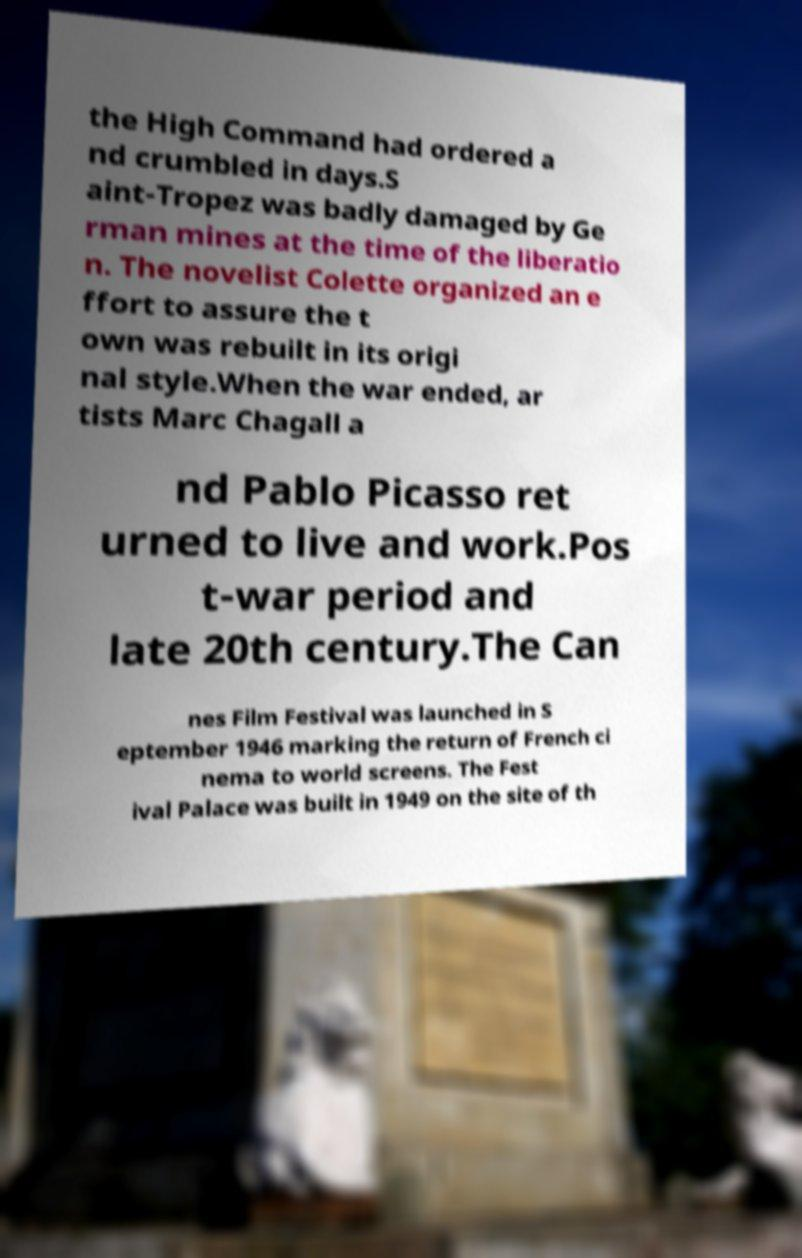I need the written content from this picture converted into text. Can you do that? the High Command had ordered a nd crumbled in days.S aint-Tropez was badly damaged by Ge rman mines at the time of the liberatio n. The novelist Colette organized an e ffort to assure the t own was rebuilt in its origi nal style.When the war ended, ar tists Marc Chagall a nd Pablo Picasso ret urned to live and work.Pos t-war period and late 20th century.The Can nes Film Festival was launched in S eptember 1946 marking the return of French ci nema to world screens. The Fest ival Palace was built in 1949 on the site of th 